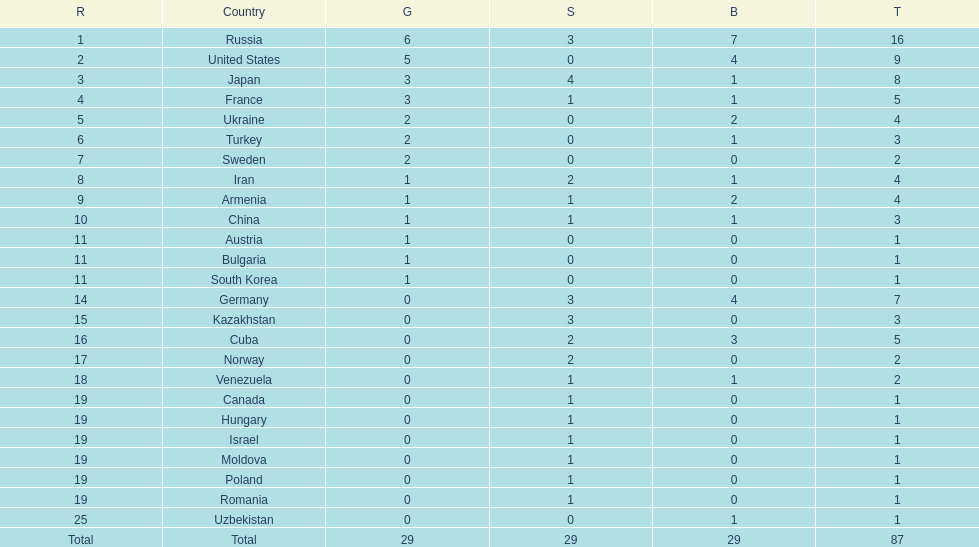Who came directly after turkey in ranking? Sweden. Can you give me this table as a dict? {'header': ['R', 'Country', 'G', 'S', 'B', 'T'], 'rows': [['1', 'Russia', '6', '3', '7', '16'], ['2', 'United States', '5', '0', '4', '9'], ['3', 'Japan', '3', '4', '1', '8'], ['4', 'France', '3', '1', '1', '5'], ['5', 'Ukraine', '2', '0', '2', '4'], ['6', 'Turkey', '2', '0', '1', '3'], ['7', 'Sweden', '2', '0', '0', '2'], ['8', 'Iran', '1', '2', '1', '4'], ['9', 'Armenia', '1', '1', '2', '4'], ['10', 'China', '1', '1', '1', '3'], ['11', 'Austria', '1', '0', '0', '1'], ['11', 'Bulgaria', '1', '0', '0', '1'], ['11', 'South Korea', '1', '0', '0', '1'], ['14', 'Germany', '0', '3', '4', '7'], ['15', 'Kazakhstan', '0', '3', '0', '3'], ['16', 'Cuba', '0', '2', '3', '5'], ['17', 'Norway', '0', '2', '0', '2'], ['18', 'Venezuela', '0', '1', '1', '2'], ['19', 'Canada', '0', '1', '0', '1'], ['19', 'Hungary', '0', '1', '0', '1'], ['19', 'Israel', '0', '1', '0', '1'], ['19', 'Moldova', '0', '1', '0', '1'], ['19', 'Poland', '0', '1', '0', '1'], ['19', 'Romania', '0', '1', '0', '1'], ['25', 'Uzbekistan', '0', '0', '1', '1'], ['Total', 'Total', '29', '29', '29', '87']]} 